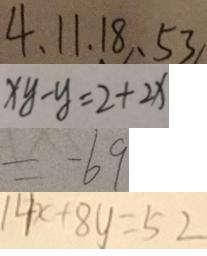Convert formula to latex. <formula><loc_0><loc_0><loc_500><loc_500>4 , 1 1 , 1 8 , 5 3 
 x y - y = 2 + 2 x 
 = - 6 9 
 1 4 x + 8 y = 5 2</formula> 